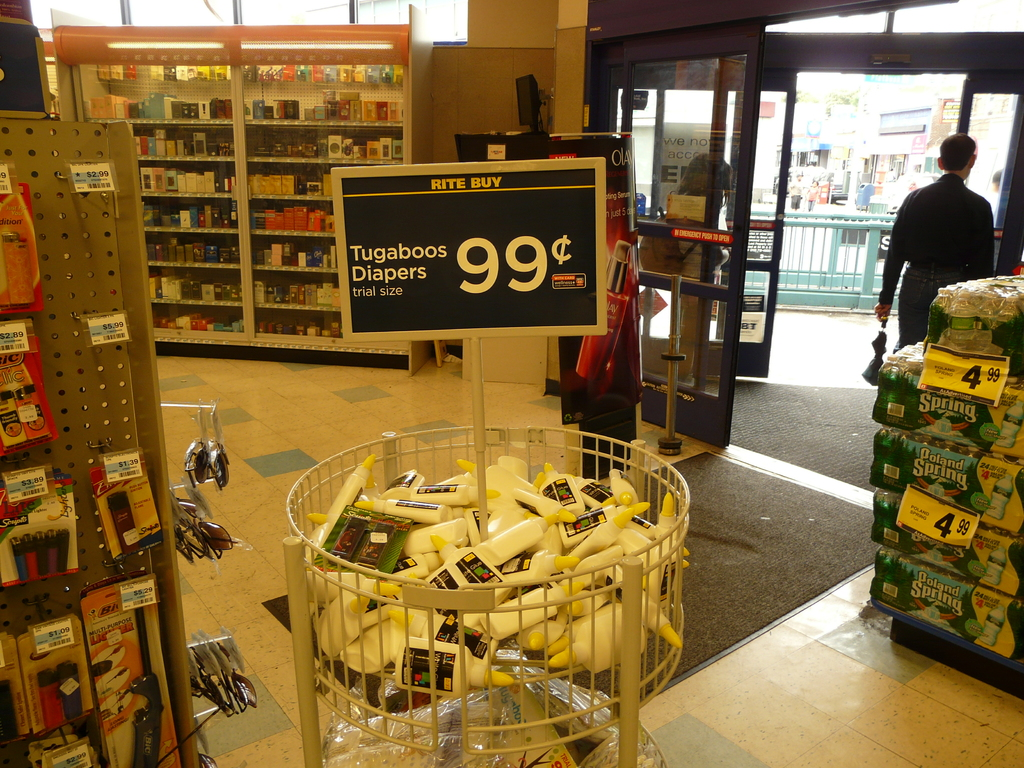Can you describe the setting of this image? The image shows the interior of a retail pharmacy. Promotional sale items are displayed at the entrance to entice shoppers. In the background, there's a person exiting the store, and the store shelves are stocked with assorted products, which suggests the photo was taken during business hours. 